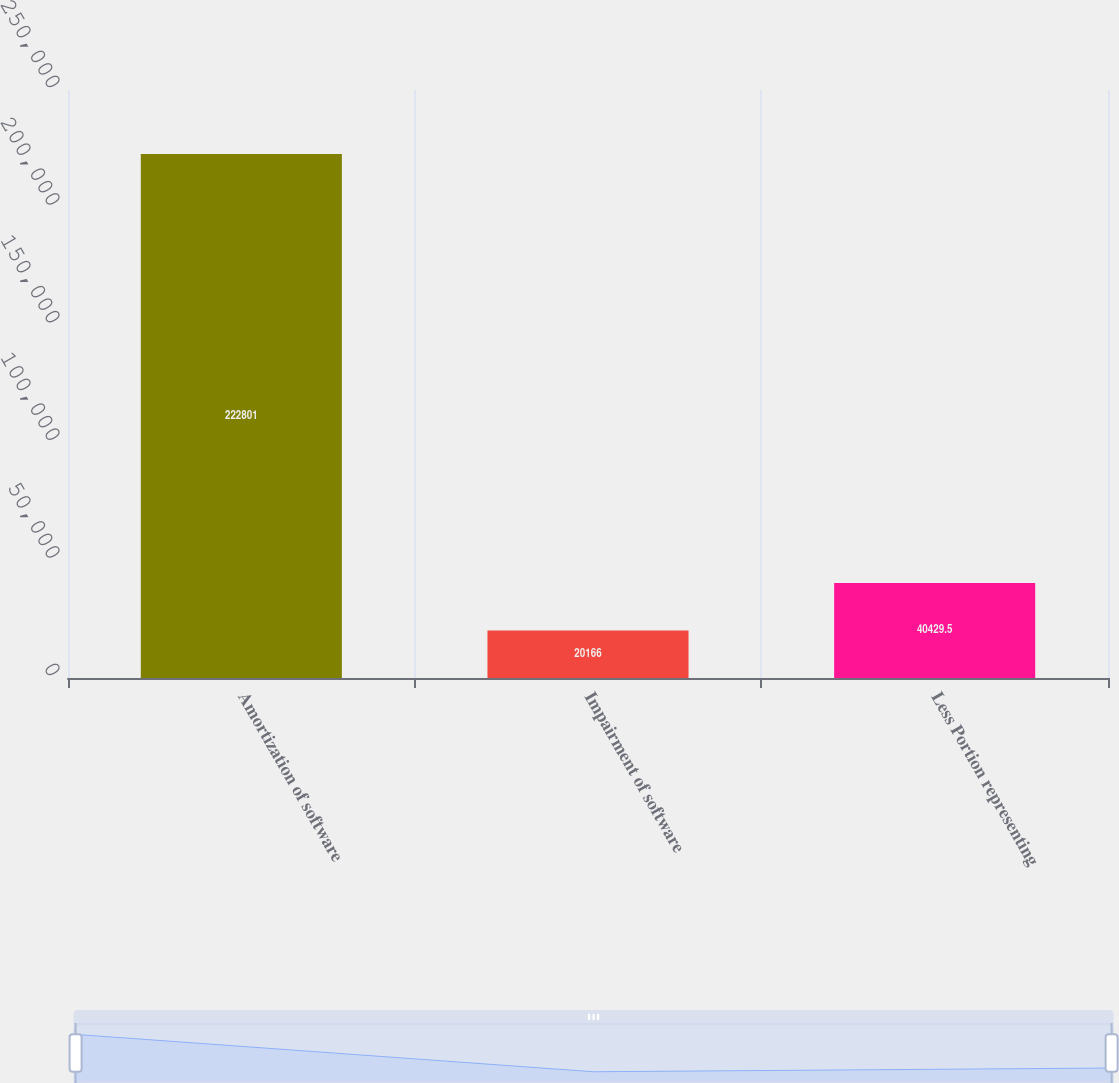<chart> <loc_0><loc_0><loc_500><loc_500><bar_chart><fcel>Amortization of software<fcel>Impairment of software<fcel>Less Portion representing<nl><fcel>222801<fcel>20166<fcel>40429.5<nl></chart> 